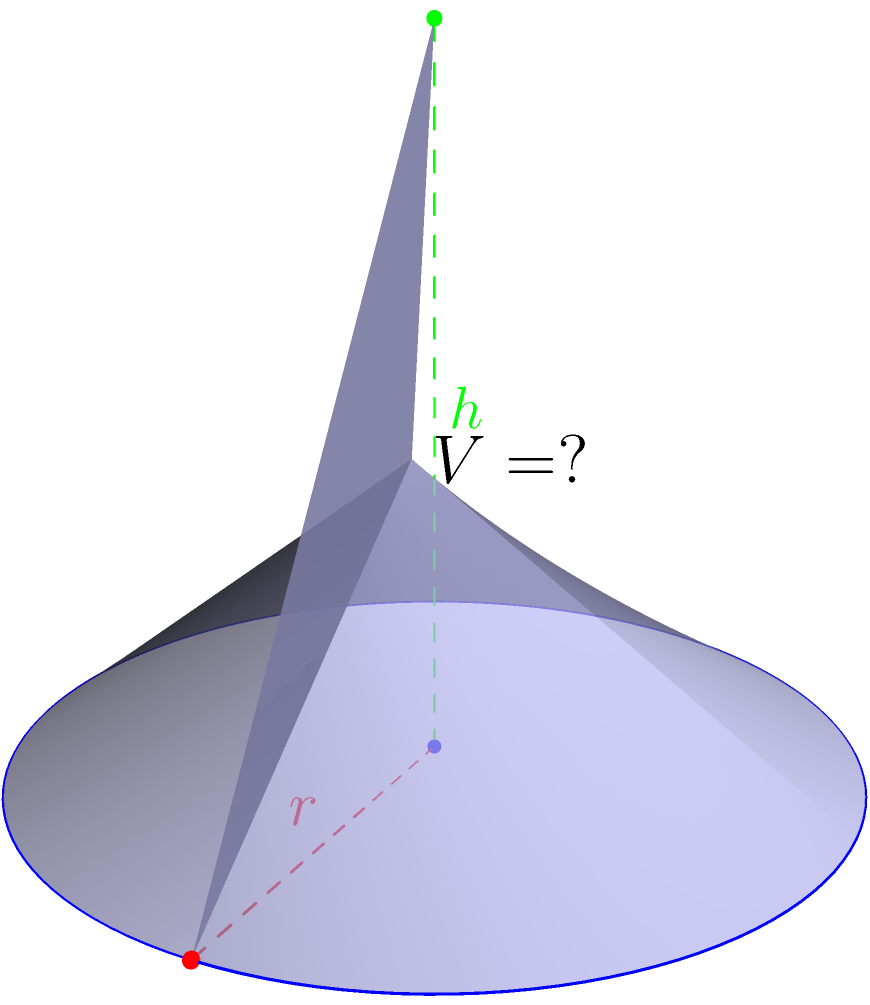At your favorite soda fountain from the good old days, you notice a conical paper drinking cup. The cup has a radius of 3 inches at the base and a height of 5 inches. What is the volume of this vintage paper cup in cubic inches? Let's approach this step-by-step:

1) The formula for the volume of a cone is:

   $$V = \frac{1}{3} \pi r^2 h$$

   Where $r$ is the radius of the base and $h$ is the height.

2) We're given:
   $r = 3$ inches
   $h = 5$ inches

3) Let's substitute these values into our formula:

   $$V = \frac{1}{3} \pi (3^2) (5)$$

4) Simplify:
   $$V = \frac{1}{3} \pi (9) (5)$$
   $$V = \frac{1}{3} \pi (45)$$
   $$V = 15\pi$$

5) If we want to calculate this exactly:
   $$V = 15 \pi \approx 47.12 \text{ cubic inches}$$

Therefore, the volume of the vintage paper cup is $15\pi$ or approximately 47.12 cubic inches.
Answer: $15\pi$ cubic inches 